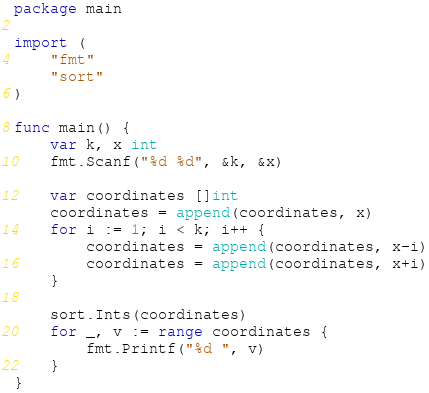Convert code to text. <code><loc_0><loc_0><loc_500><loc_500><_Go_>package main

import (
	"fmt"
	"sort"
)

func main() {
	var k, x int
	fmt.Scanf("%d %d", &k, &x)

	var coordinates []int
	coordinates = append(coordinates, x)
	for i := 1; i < k; i++ {
		coordinates = append(coordinates, x-i)
		coordinates = append(coordinates, x+i)
	}

	sort.Ints(coordinates)
	for _, v := range coordinates {
		fmt.Printf("%d ", v)
	}
}
</code> 